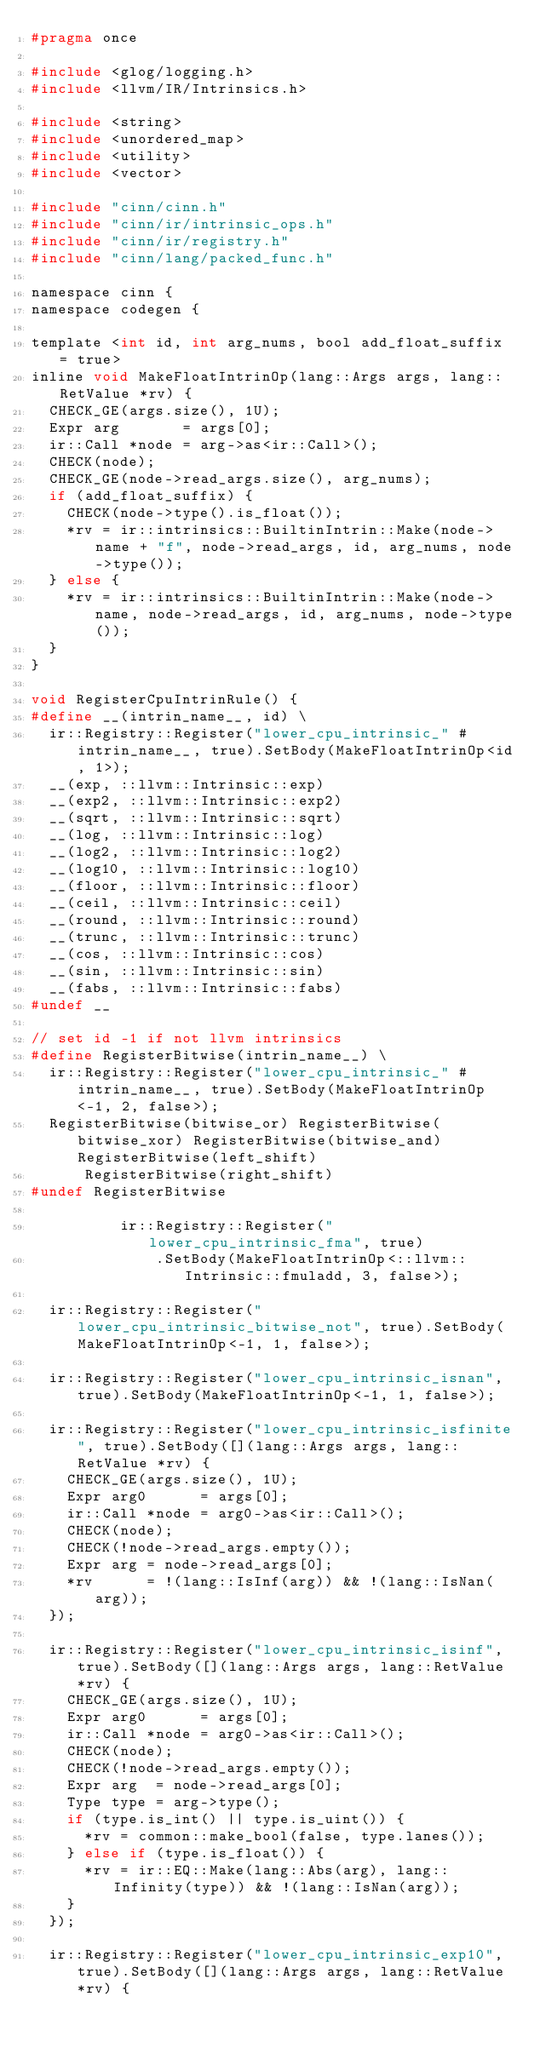Convert code to text. <code><loc_0><loc_0><loc_500><loc_500><_C_>#pragma once

#include <glog/logging.h>
#include <llvm/IR/Intrinsics.h>

#include <string>
#include <unordered_map>
#include <utility>
#include <vector>

#include "cinn/cinn.h"
#include "cinn/ir/intrinsic_ops.h"
#include "cinn/ir/registry.h"
#include "cinn/lang/packed_func.h"

namespace cinn {
namespace codegen {

template <int id, int arg_nums, bool add_float_suffix = true>
inline void MakeFloatIntrinOp(lang::Args args, lang::RetValue *rv) {
  CHECK_GE(args.size(), 1U);
  Expr arg       = args[0];
  ir::Call *node = arg->as<ir::Call>();
  CHECK(node);
  CHECK_GE(node->read_args.size(), arg_nums);
  if (add_float_suffix) {
    CHECK(node->type().is_float());
    *rv = ir::intrinsics::BuiltinIntrin::Make(node->name + "f", node->read_args, id, arg_nums, node->type());
  } else {
    *rv = ir::intrinsics::BuiltinIntrin::Make(node->name, node->read_args, id, arg_nums, node->type());
  }
}

void RegisterCpuIntrinRule() {
#define __(intrin_name__, id) \
  ir::Registry::Register("lower_cpu_intrinsic_" #intrin_name__, true).SetBody(MakeFloatIntrinOp<id, 1>);
  __(exp, ::llvm::Intrinsic::exp)
  __(exp2, ::llvm::Intrinsic::exp2)
  __(sqrt, ::llvm::Intrinsic::sqrt)
  __(log, ::llvm::Intrinsic::log)
  __(log2, ::llvm::Intrinsic::log2)
  __(log10, ::llvm::Intrinsic::log10)
  __(floor, ::llvm::Intrinsic::floor)
  __(ceil, ::llvm::Intrinsic::ceil)
  __(round, ::llvm::Intrinsic::round)
  __(trunc, ::llvm::Intrinsic::trunc)
  __(cos, ::llvm::Intrinsic::cos)
  __(sin, ::llvm::Intrinsic::sin)
  __(fabs, ::llvm::Intrinsic::fabs)
#undef __

// set id -1 if not llvm intrinsics
#define RegisterBitwise(intrin_name__) \
  ir::Registry::Register("lower_cpu_intrinsic_" #intrin_name__, true).SetBody(MakeFloatIntrinOp<-1, 2, false>);
  RegisterBitwise(bitwise_or) RegisterBitwise(bitwise_xor) RegisterBitwise(bitwise_and) RegisterBitwise(left_shift)
      RegisterBitwise(right_shift)
#undef RegisterBitwise

          ir::Registry::Register("lower_cpu_intrinsic_fma", true)
              .SetBody(MakeFloatIntrinOp<::llvm::Intrinsic::fmuladd, 3, false>);

  ir::Registry::Register("lower_cpu_intrinsic_bitwise_not", true).SetBody(MakeFloatIntrinOp<-1, 1, false>);

  ir::Registry::Register("lower_cpu_intrinsic_isnan", true).SetBody(MakeFloatIntrinOp<-1, 1, false>);

  ir::Registry::Register("lower_cpu_intrinsic_isfinite", true).SetBody([](lang::Args args, lang::RetValue *rv) {
    CHECK_GE(args.size(), 1U);
    Expr arg0      = args[0];
    ir::Call *node = arg0->as<ir::Call>();
    CHECK(node);
    CHECK(!node->read_args.empty());
    Expr arg = node->read_args[0];
    *rv      = !(lang::IsInf(arg)) && !(lang::IsNan(arg));
  });

  ir::Registry::Register("lower_cpu_intrinsic_isinf", true).SetBody([](lang::Args args, lang::RetValue *rv) {
    CHECK_GE(args.size(), 1U);
    Expr arg0      = args[0];
    ir::Call *node = arg0->as<ir::Call>();
    CHECK(node);
    CHECK(!node->read_args.empty());
    Expr arg  = node->read_args[0];
    Type type = arg->type();
    if (type.is_int() || type.is_uint()) {
      *rv = common::make_bool(false, type.lanes());
    } else if (type.is_float()) {
      *rv = ir::EQ::Make(lang::Abs(arg), lang::Infinity(type)) && !(lang::IsNan(arg));
    }
  });

  ir::Registry::Register("lower_cpu_intrinsic_exp10", true).SetBody([](lang::Args args, lang::RetValue *rv) {</code> 